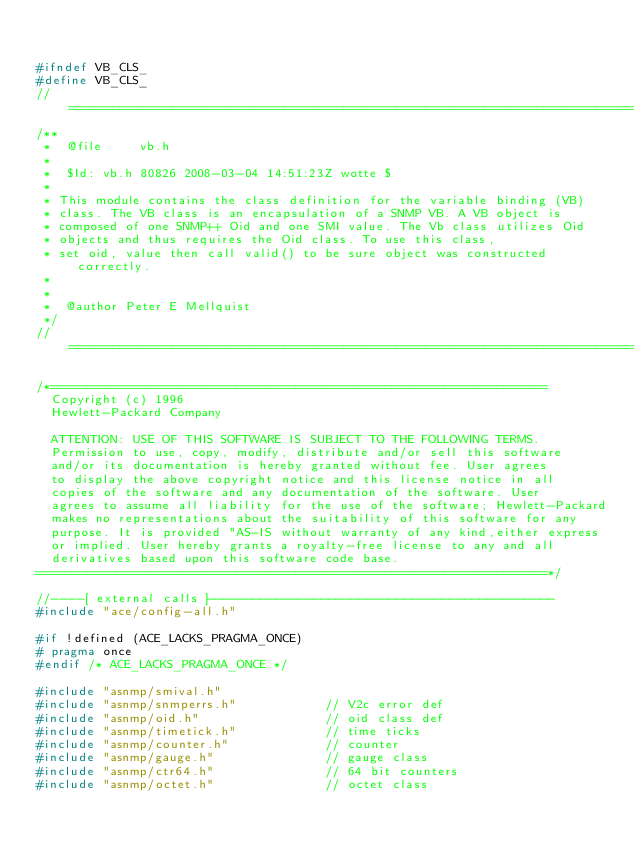Convert code to text. <code><loc_0><loc_0><loc_500><loc_500><_C_>

#ifndef VB_CLS_
#define VB_CLS_
//=============================================================================
/**
 *  @file     vb.h
 *
 *  $Id: vb.h 80826 2008-03-04 14:51:23Z wotte $
 *
 * This module contains the class definition for the variable binding (VB)
 * class. The VB class is an encapsulation of a SNMP VB. A VB object is
 * composed of one SNMP++ Oid and one SMI value. The Vb class utilizes Oid
 * objects and thus requires the Oid class. To use this class,
 * set oid, value then call valid() to be sure object was constructed correctly.
 *
 *
 *  @author Peter E Mellquist
 */
//=============================================================================

/*===================================================================
  Copyright (c) 1996
  Hewlett-Packard Company

  ATTENTION: USE OF THIS SOFTWARE IS SUBJECT TO THE FOLLOWING TERMS.
  Permission to use, copy, modify, distribute and/or sell this software
  and/or its documentation is hereby granted without fee. User agrees
  to display the above copyright notice and this license notice in all
  copies of the software and any documentation of the software. User
  agrees to assume all liability for the use of the software; Hewlett-Packard
  makes no representations about the suitability of this software for any
  purpose. It is provided "AS-IS without warranty of any kind,either express
  or implied. User hereby grants a royalty-free license to any and all
  derivatives based upon this software code base.
=====================================================================*/

//----[ external calls ]----------------------------------------------
#include "ace/config-all.h"

#if !defined (ACE_LACKS_PRAGMA_ONCE)
# pragma once
#endif /* ACE_LACKS_PRAGMA_ONCE */

#include "asnmp/smival.h"
#include "asnmp/snmperrs.h"            // V2c error def
#include "asnmp/oid.h"                 // oid class def
#include "asnmp/timetick.h"            // time ticks
#include "asnmp/counter.h"             // counter
#include "asnmp/gauge.h"               // gauge class
#include "asnmp/ctr64.h"               // 64 bit counters
#include "asnmp/octet.h"               // octet class</code> 